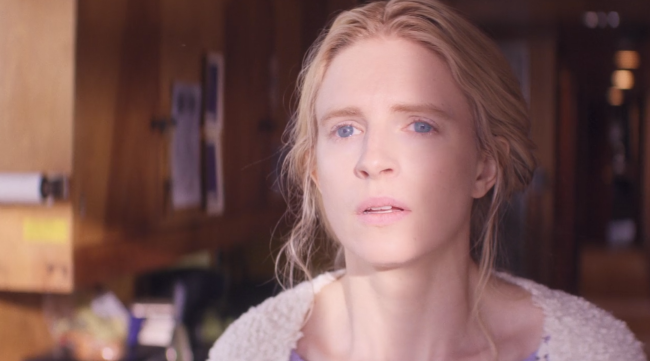If you could hear the woman's thoughts, what might she be saying? "I wonder if things could have turned out differently. Did I make the right choice? It's hard to see the path ahead, but I need to keep moving forward. I can find peace in the memories, but they also bring a bittersweet feeling." 